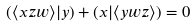Convert formula to latex. <formula><loc_0><loc_0><loc_500><loc_500>( \langle x z w \rangle | y ) + ( x | \langle y w z \rangle ) = 0</formula> 